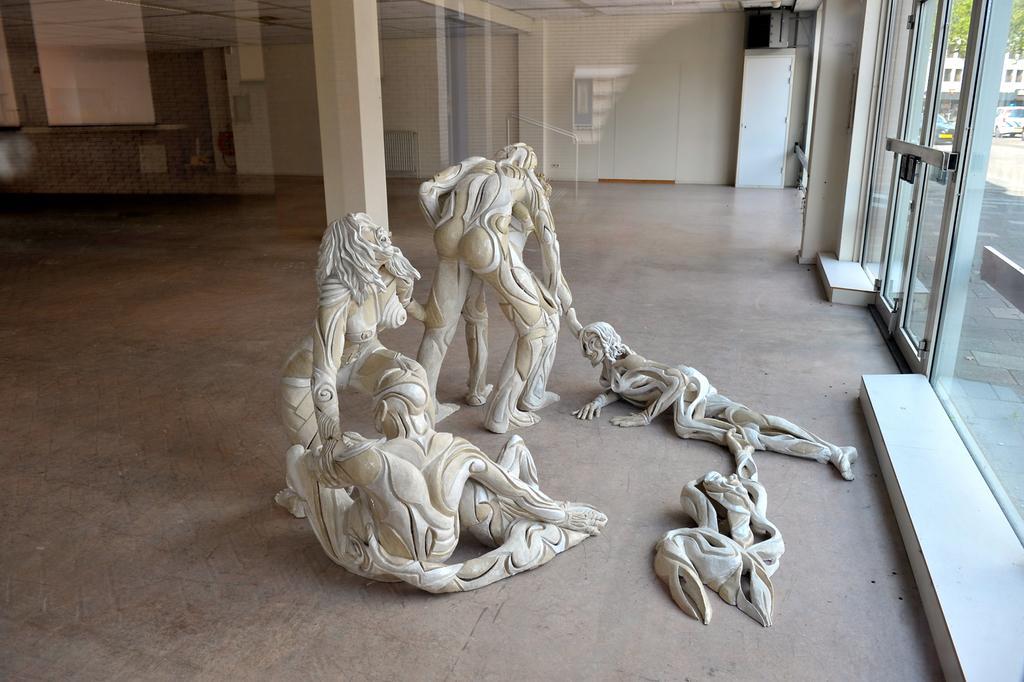Can you describe this image briefly? There are statues present on the floor a we can see in the middle of this image. We can see the pillars and a wall in the background. There is a glass door on the right side of this image. 